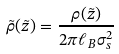Convert formula to latex. <formula><loc_0><loc_0><loc_500><loc_500>\tilde { \rho } ( \tilde { z } ) = \frac { \rho ( \tilde { z } ) } { 2 \pi \ell _ { B } \sigma _ { s } ^ { 2 } }</formula> 